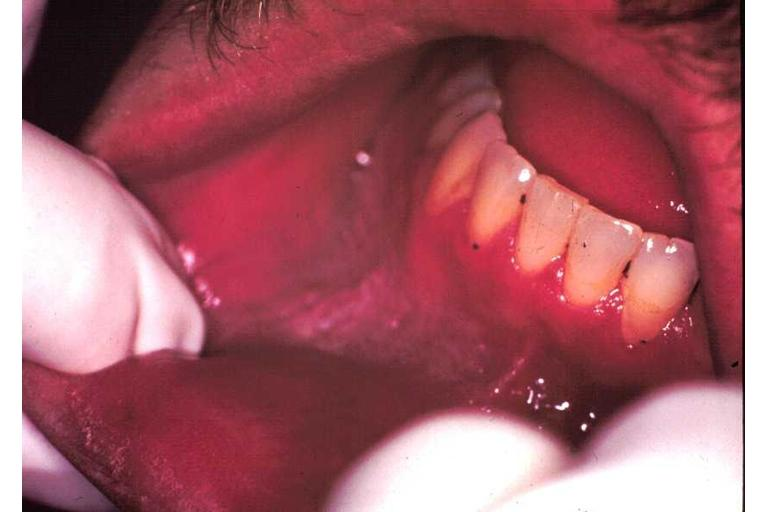where is this?
Answer the question using a single word or phrase. Oral 